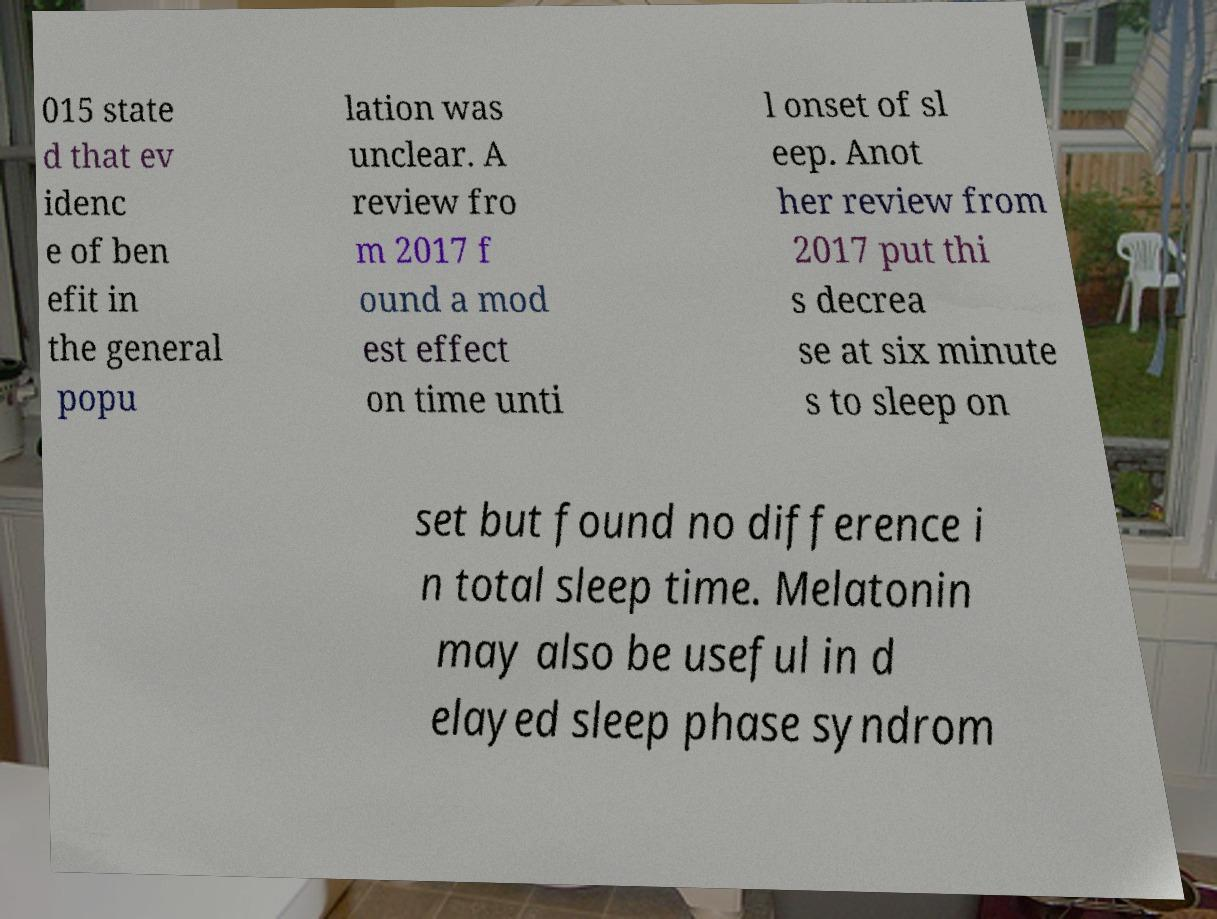I need the written content from this picture converted into text. Can you do that? 015 state d that ev idenc e of ben efit in the general popu lation was unclear. A review fro m 2017 f ound a mod est effect on time unti l onset of sl eep. Anot her review from 2017 put thi s decrea se at six minute s to sleep on set but found no difference i n total sleep time. Melatonin may also be useful in d elayed sleep phase syndrom 